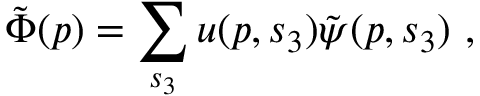<formula> <loc_0><loc_0><loc_500><loc_500>\tilde { \Phi } ( p ) = \sum _ { s _ { 3 } } u ( p , s _ { 3 } ) \tilde { \psi } ( p , s _ { 3 } ) \, , \,</formula> 